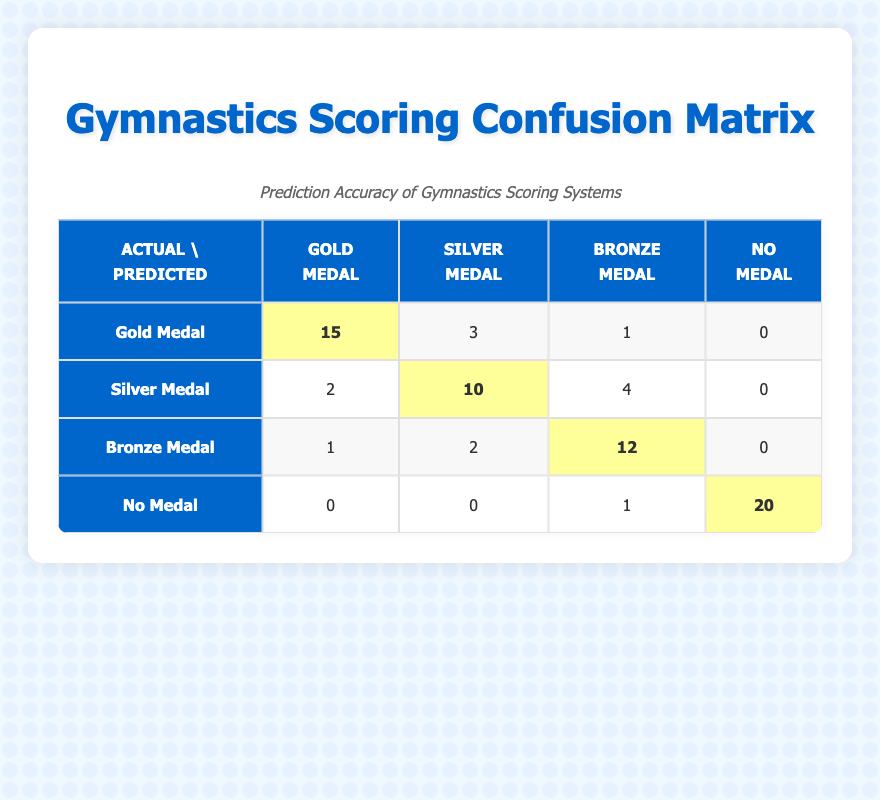What is the number of times a Gold Medal was predicted correctly? From the table, the predicted Gold Medal matches the actual Gold Medal 15 times.
Answer: 15 How many times were Silver Medals predicted overall? For Silver Medals, look at the second row: predicted Silver Medals occurred 10 times (actual Silver Medal) + 3 times (actual Gold Medal) + 2 times (actual Bronze Medal) = 15 times.
Answer: 15 What is the total number of medals awarded? Adding all values from the table: 15 (Gold) + 3 (Gold) + 1 (Gold) + 2 (Silver) + 10 (Silver) + 4 (Silver) + 1 (Bronze) + 2 (Bronze) + 12 (Bronze) + 20 (No Medal) + 1 (No Medal) = 70 medals awarded in total.
Answer: 70 Is it true that there were no instances where a Silver Medal was predicted as a No Medal? In the table, under "Silver Medal" actual, the predicted No Medal count is zero. Thus, it is true there are no instances.
Answer: Yes What is the percentage of correct predictions for Bronze Medals? Correct predictions for Bronze Medals are 12 (predicted Bronze and actual Bronze) out of total predictions for Bronze, which is 12 (Bronze) + 1 (Gold) + 2 (Silver) = 15. So, (12/15) * 100 = 80%.
Answer: 80% 